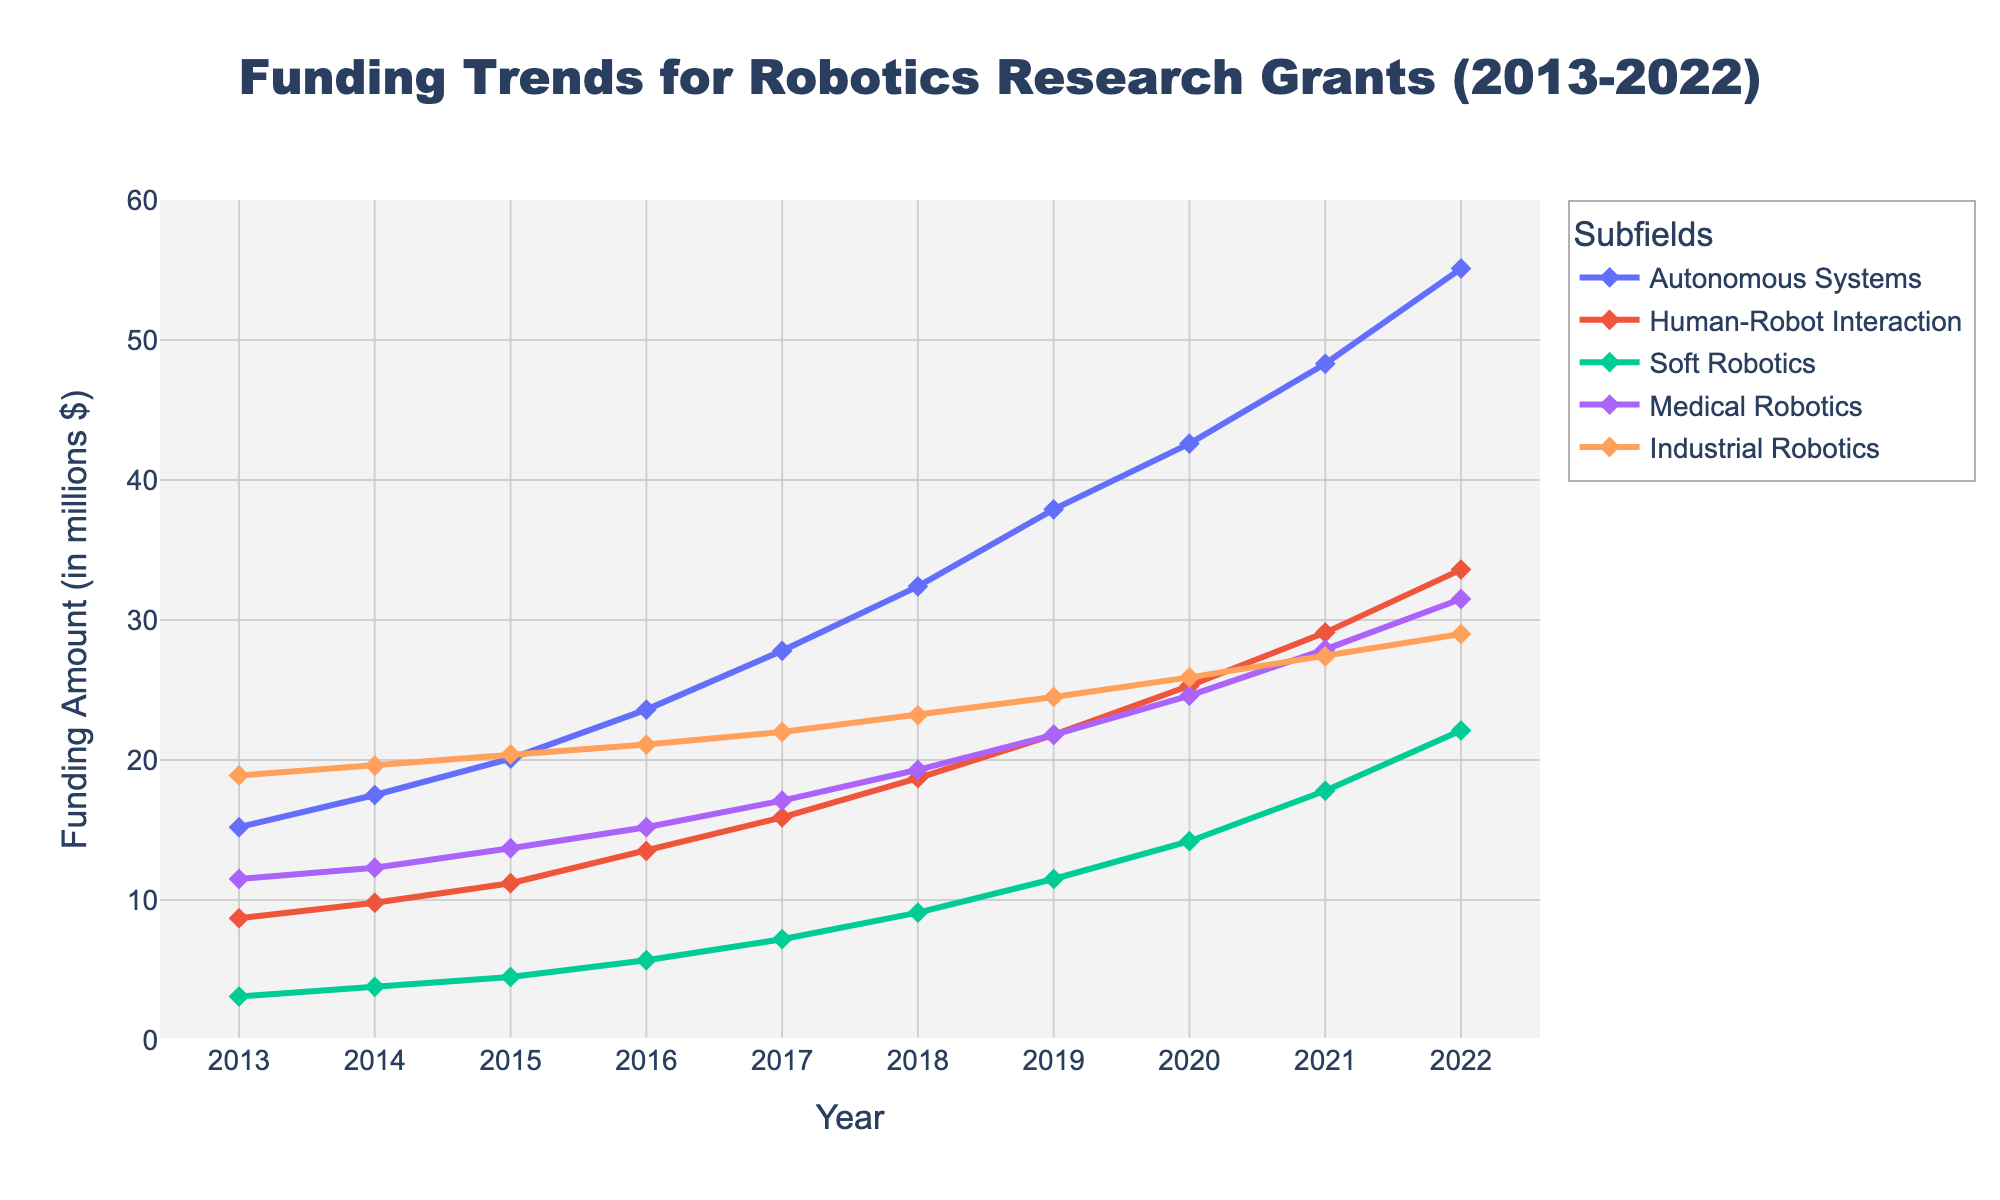Which subfield of robotics experienced the highest funding in 2013? By looking at the 2013 data points, we see that Industrial Robotics has the highest value, indicated by the highest marker on the y-axis.
Answer: Industrial Robotics Which subfield saw the largest increase in funding between 2013 and 2022? Comparing the starting and ending values for each subfield, we notice Autonomous Systems increased from 15.2 million to 55.1 million, which is the largest increase.
Answer: Autonomous Systems Between 2019 and 2020, which subfield had the smallest increase in funding? By looking at the differences between 2019 and 2020 for all subfields, Industrial Robotics increased from 24.5 million to 25.9 million, the smallest increase of 1.4 million.
Answer: Industrial Robotics What is the total funding amount for Human-Robot Interaction, Soft Robotics, and Medical Robotics in 2022? Adding the 2022 values for Human-Robot Interaction (33.6), Soft Robotics (22.1), and Medical Robotics (31.5), we get a total of 87.2 million.
Answer: 87.2 million Which year did Medical Robotics surpass 20 million in funding for the first time? Tracing the Medical Robotics line until a value greater than 20 million is found, it surpasses 20 million in 2019 with 21.8 million.
Answer: 2019 How did the funding trends for Autonomous Systems and Industrial Robotics compare in 2021? By looking at the 2021 data, Autonomous Systems had 48.3 million while Industrial Robotics had 27.4 million, showing that Autonomous Systems had significantly higher funding.
Answer: Autonomous Systems had higher funding What is the average funding for Soft Robotics over the entire period? Summing the values for Soft Robotics from 2013 to 2022 (3.1, 3.8, 4.5, 5.7, 7.2, 9.1, 11.5, 14.2, 17.8, 22.1) gives 98, dividing by 10 years gives an average of 9.8 million.
Answer: 9.8 million Which subfield has consistently shown a gradual increase in funding every year? Reviewing the trend lines, every subfield shows a steady increase each year, but Human-Robot Interaction showcases a consistent gradual rise without any major jumps.
Answer: Human-Robot Interaction What was the total funding for all subfields combined in 2015? Adding the values in 2015 for all subfields (20.1 + 11.2 + 4.5 + 13.7 + 20.4) gives 69.9 million.
Answer: 69.9 million In which year did all five subfields collectively receive more than 100 million in funding for the first time? Summing the funding amounts for each year, we notice in 2016, the total (23.6 + 13.5 + 5.7 + 15.2 + 21.1) equals 79.1 million. It is not until 2017, with a total of (27.8 + 15.9 + 7.2 + 17.1 + 22.0) reaching 90 million, does the total funding cross 100 million.
Answer: 2017 